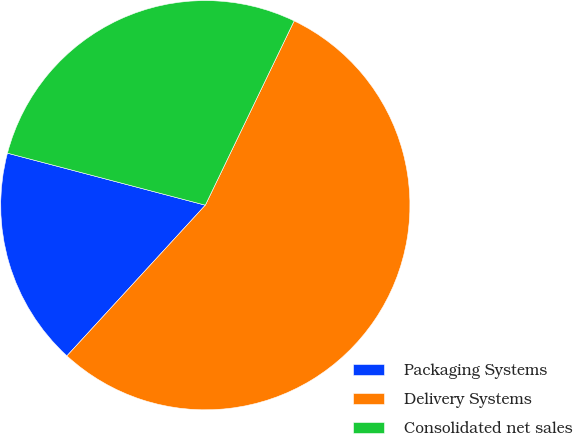Convert chart. <chart><loc_0><loc_0><loc_500><loc_500><pie_chart><fcel>Packaging Systems<fcel>Delivery Systems<fcel>Consolidated net sales<nl><fcel>17.27%<fcel>54.68%<fcel>28.06%<nl></chart> 